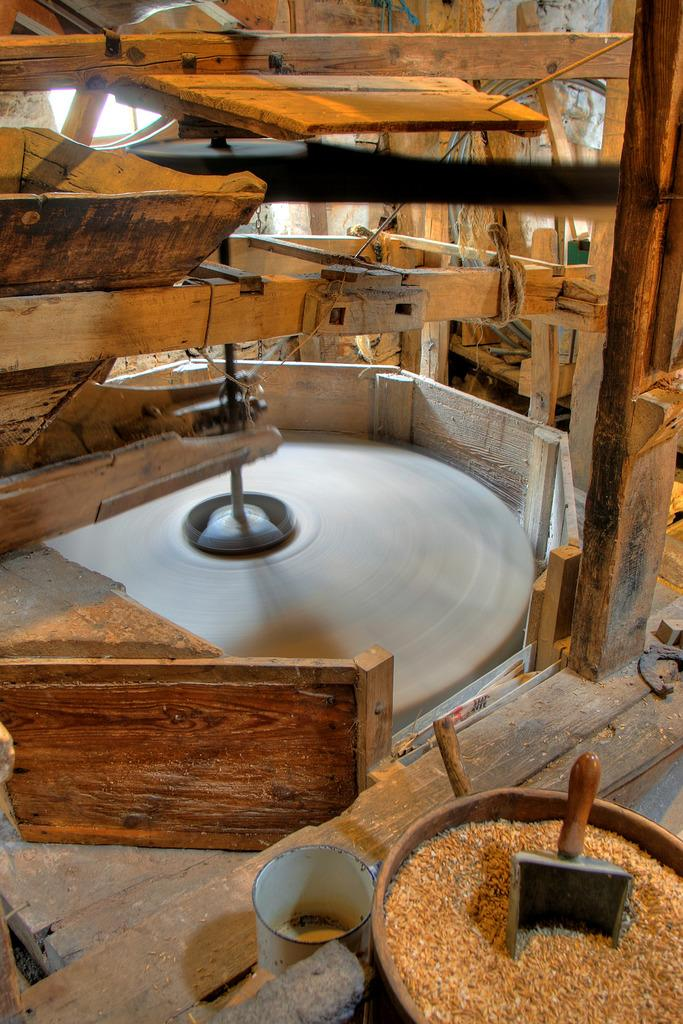What type of material is the object in the image made of? The object in the image is made of wood. Where are the grains located in the image? The grains are in the right bottom corner of the image. How many cows can be seen crossing the stream in the image? There is no stream or cows present in the image. 